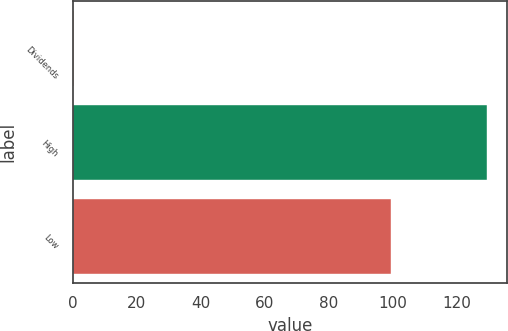<chart> <loc_0><loc_0><loc_500><loc_500><bar_chart><fcel>Dividends<fcel>High<fcel>Low<nl><fcel>0.35<fcel>129.36<fcel>99.38<nl></chart> 